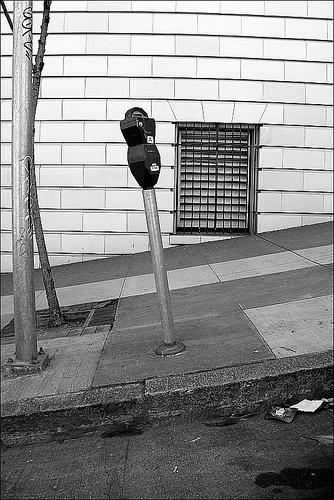What color is the top of the meter?
Answer briefly. Black. Where is the parking meter?
Keep it brief. Sidewalk. How many trees are in this picture?
Keep it brief. 1. 